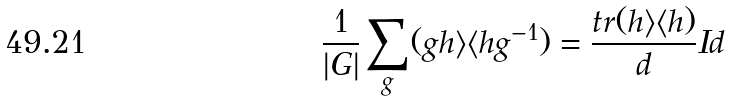<formula> <loc_0><loc_0><loc_500><loc_500>\frac { 1 } { | G | } \sum _ { g } ( g h \rangle \langle h g ^ { - 1 } ) = \frac { t r ( h \rangle \langle h ) } { d } I d</formula> 